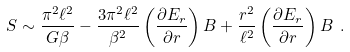Convert formula to latex. <formula><loc_0><loc_0><loc_500><loc_500>S \sim \frac { \pi ^ { 2 } \ell ^ { 2 } } { G \beta } - \frac { 3 \pi ^ { 2 } \ell ^ { 2 } } { \beta ^ { 2 } } \left ( \frac { \partial E _ { r } } { \partial r } \right ) B + \frac { r ^ { 2 } } { \ell ^ { 2 } } \left ( \frac { \partial E _ { r } } { \partial r } \right ) B \ .</formula> 